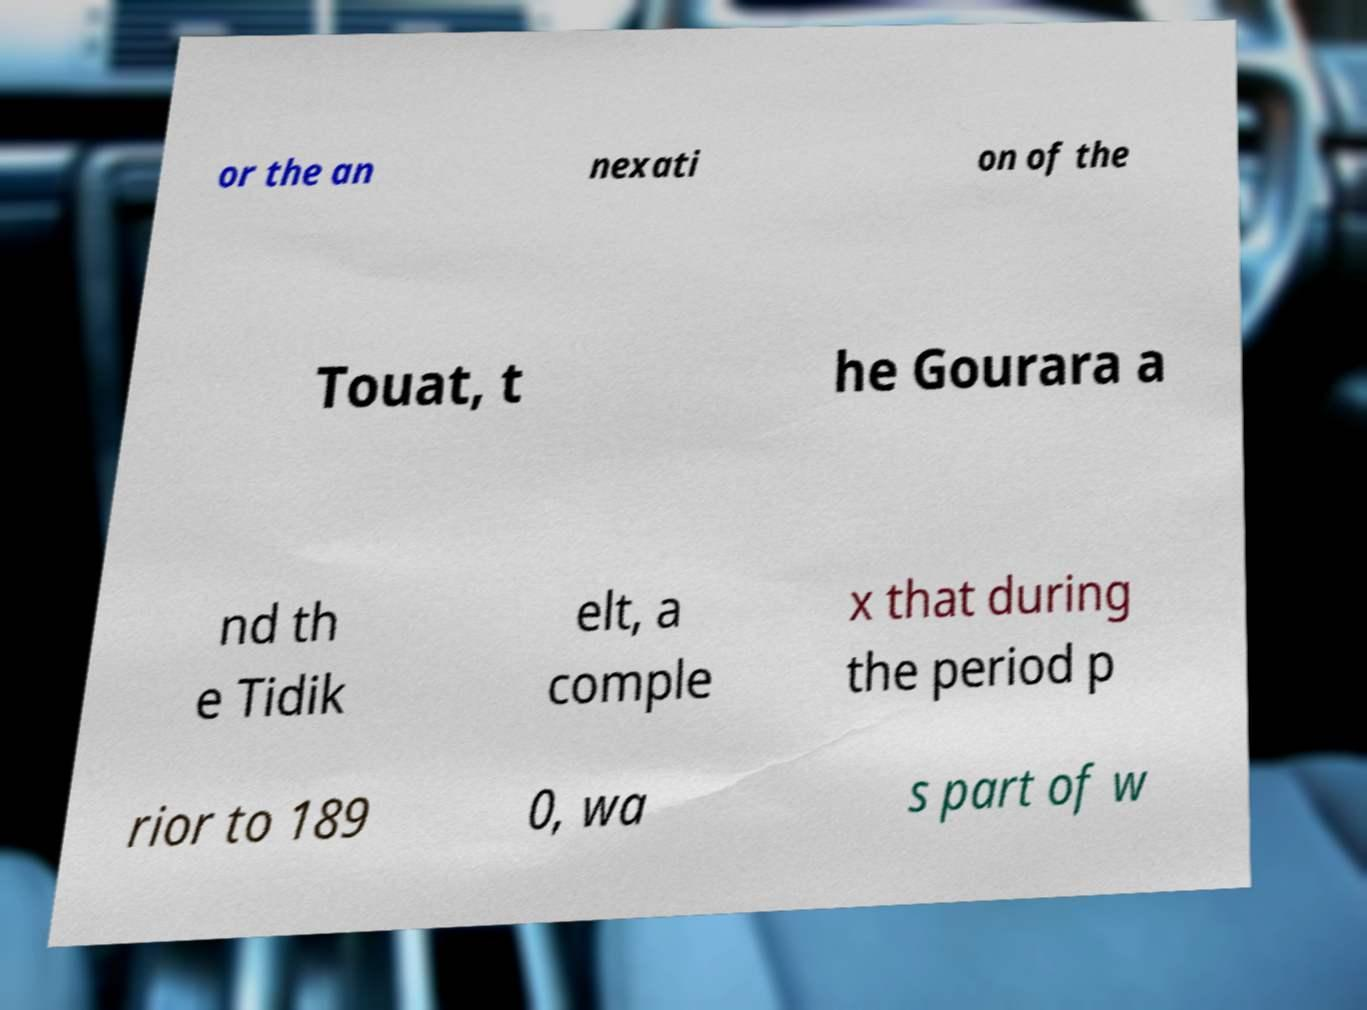Can you read and provide the text displayed in the image?This photo seems to have some interesting text. Can you extract and type it out for me? or the an nexati on of the Touat, t he Gourara a nd th e Tidik elt, a comple x that during the period p rior to 189 0, wa s part of w 